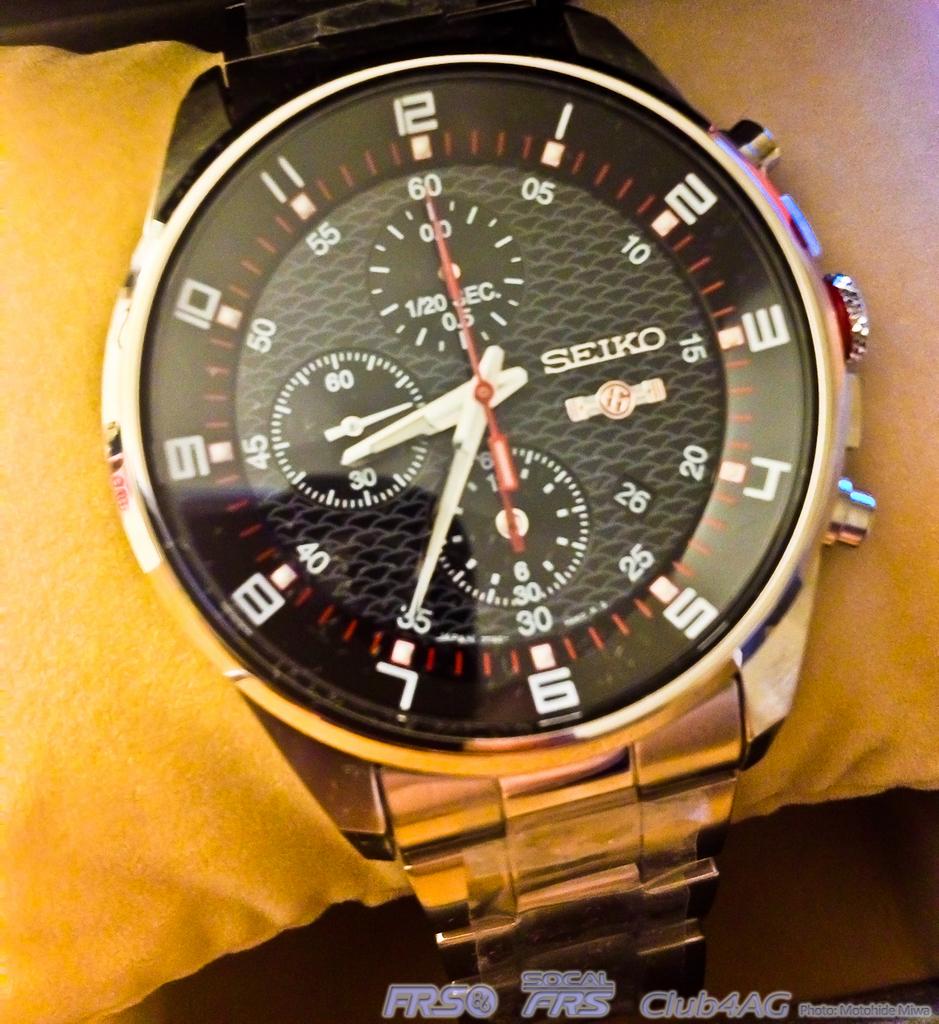What brand of watch is this?
Keep it short and to the point. Seiko. 